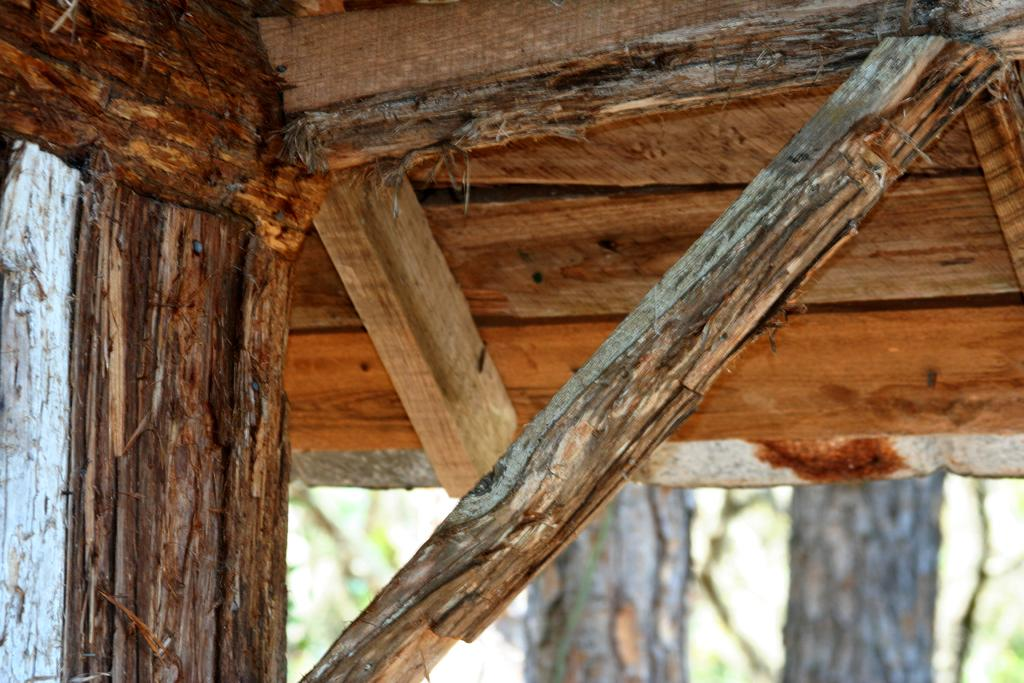What is the main structure visible in the image? There is a roof in the image. What material is used for the roof? The roof has wooden planks attached to it. What can be seen at the bottom of the image? There are trees visible at the bottom of the image. How many oranges are hanging from the roof in the image? There are no oranges present in the image. Is there a hole in the roof that is filled with eggnog? There is no hole or eggnog present in the image. 